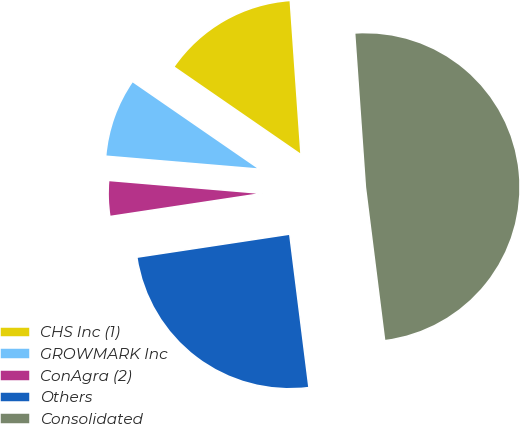Convert chart. <chart><loc_0><loc_0><loc_500><loc_500><pie_chart><fcel>CHS Inc (1)<fcel>GROWMARK Inc<fcel>ConAgra (2)<fcel>Others<fcel>Consolidated<nl><fcel>14.28%<fcel>8.27%<fcel>3.73%<fcel>24.6%<fcel>49.13%<nl></chart> 